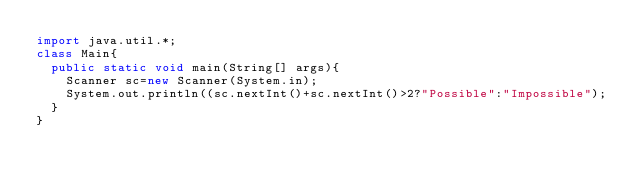<code> <loc_0><loc_0><loc_500><loc_500><_Java_>import java.util.*;
class Main{
  public static void main(String[] args){
    Scanner sc=new Scanner(System.in);
    System.out.println((sc.nextInt()+sc.nextInt()>2?"Possible":"Impossible");
  }
}
</code> 